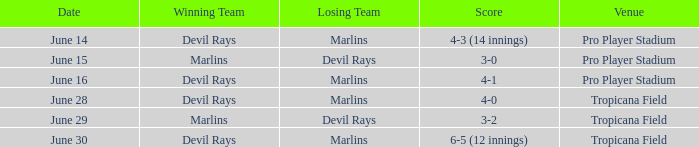I'm looking to parse the entire table for insights. Could you assist me with that? {'header': ['Date', 'Winning Team', 'Losing Team', 'Score', 'Venue'], 'rows': [['June 14', 'Devil Rays', 'Marlins', '4-3 (14 innings)', 'Pro Player Stadium'], ['June 15', 'Marlins', 'Devil Rays', '3-0', 'Pro Player Stadium'], ['June 16', 'Devil Rays', 'Marlins', '4-1', 'Pro Player Stadium'], ['June 28', 'Devil Rays', 'Marlins', '4-0', 'Tropicana Field'], ['June 29', 'Marlins', 'Devil Rays', '3-2', 'Tropicana Field'], ['June 30', 'Devil Rays', 'Marlins', '6-5 (12 innings)', 'Tropicana Field']]} What was the score of the game at pro player stadium on june 14? 4-3 (14 innings). 